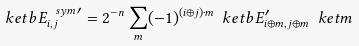Convert formula to latex. <formula><loc_0><loc_0><loc_500><loc_500>\ k e t b { E ^ { \ s y m \, \prime } _ { i , j } } = 2 ^ { - n } \sum _ { m } ( - 1 ) ^ { ( i \oplus j ) \cdot m } \ k e t b { E ^ { \prime } _ { i \oplus m , j \oplus m } } \ k e t { m }</formula> 